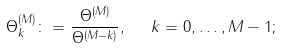Convert formula to latex. <formula><loc_0><loc_0><loc_500><loc_500>\Theta ^ { ( M ) } _ { k } \colon = \frac { \Theta ^ { ( M ) } } { \Theta ^ { ( M - k ) } } , \ \ k = 0 , \dots , M - 1 ;</formula> 